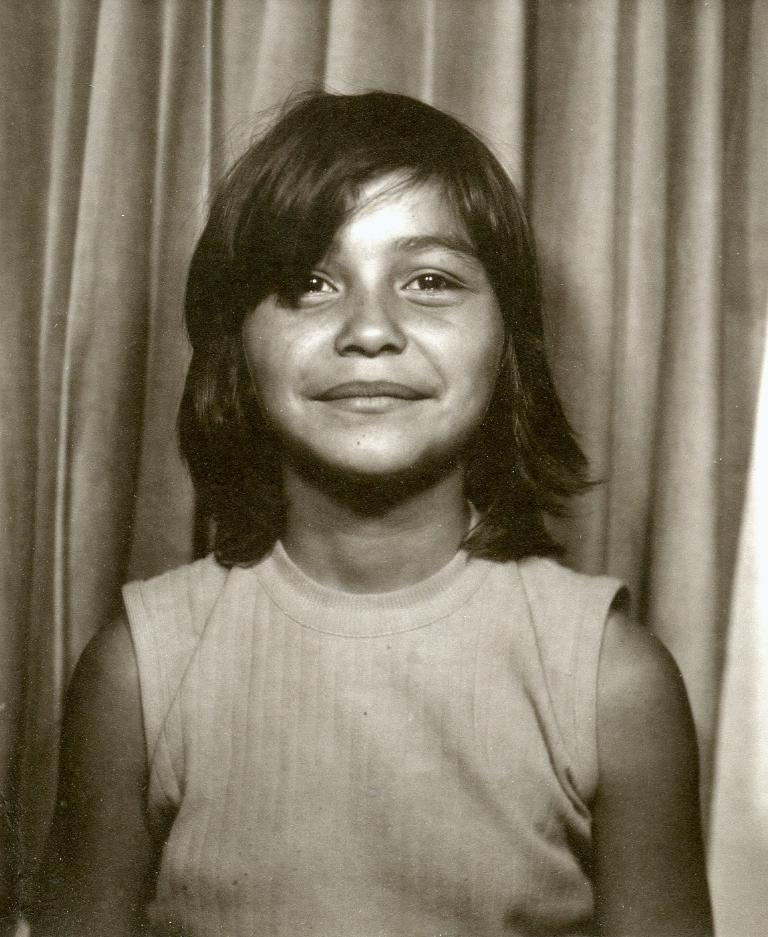Could you give a brief overview of what you see in this image? In this image I can see a girl is there, she is wearing a t-shirt, behind her it looks like a curtain. 